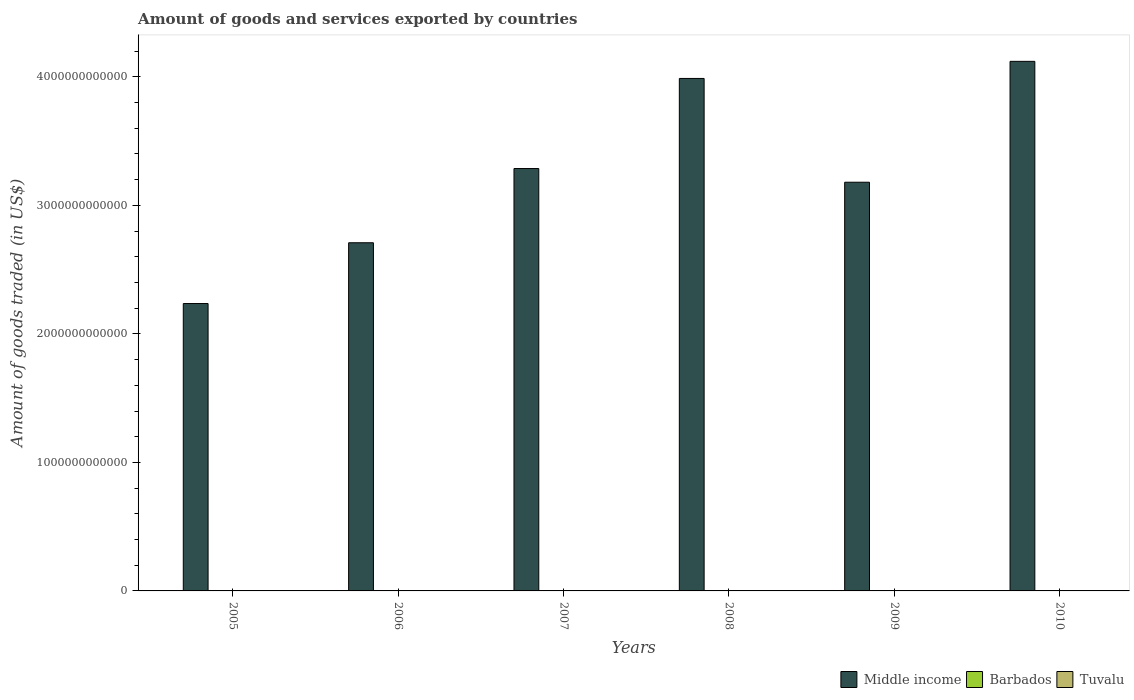How many groups of bars are there?
Your answer should be very brief. 6. Are the number of bars on each tick of the X-axis equal?
Offer a very short reply. Yes. How many bars are there on the 3rd tick from the left?
Your answer should be compact. 3. What is the label of the 4th group of bars from the left?
Offer a very short reply. 2008. In how many cases, is the number of bars for a given year not equal to the number of legend labels?
Your answer should be compact. 0. What is the total amount of goods and services exported in Middle income in 2007?
Your response must be concise. 3.29e+12. Across all years, what is the maximum total amount of goods and services exported in Barbados?
Offer a very short reply. 5.25e+08. Across all years, what is the minimum total amount of goods and services exported in Barbados?
Provide a short and direct response. 3.61e+08. In which year was the total amount of goods and services exported in Barbados maximum?
Your response must be concise. 2007. What is the total total amount of goods and services exported in Barbados in the graph?
Make the answer very short. 2.70e+09. What is the difference between the total amount of goods and services exported in Barbados in 2005 and that in 2007?
Your answer should be very brief. -1.64e+08. What is the difference between the total amount of goods and services exported in Barbados in 2008 and the total amount of goods and services exported in Tuvalu in 2010?
Your answer should be very brief. 4.79e+08. What is the average total amount of goods and services exported in Middle income per year?
Your answer should be very brief. 3.25e+12. In the year 2008, what is the difference between the total amount of goods and services exported in Tuvalu and total amount of goods and services exported in Barbados?
Provide a succinct answer. -4.89e+08. What is the ratio of the total amount of goods and services exported in Middle income in 2007 to that in 2009?
Provide a succinct answer. 1.03. Is the difference between the total amount of goods and services exported in Tuvalu in 2008 and 2010 greater than the difference between the total amount of goods and services exported in Barbados in 2008 and 2010?
Ensure brevity in your answer.  No. What is the difference between the highest and the second highest total amount of goods and services exported in Tuvalu?
Make the answer very short. 7.44e+06. What is the difference between the highest and the lowest total amount of goods and services exported in Tuvalu?
Provide a succinct answer. 9.68e+06. In how many years, is the total amount of goods and services exported in Tuvalu greater than the average total amount of goods and services exported in Tuvalu taken over all years?
Keep it short and to the point. 2. Is the sum of the total amount of goods and services exported in Middle income in 2007 and 2010 greater than the maximum total amount of goods and services exported in Barbados across all years?
Give a very brief answer. Yes. What does the 1st bar from the right in 2007 represents?
Make the answer very short. Tuvalu. How many years are there in the graph?
Offer a very short reply. 6. What is the difference between two consecutive major ticks on the Y-axis?
Your answer should be compact. 1.00e+12. Are the values on the major ticks of Y-axis written in scientific E-notation?
Provide a short and direct response. No. How are the legend labels stacked?
Provide a succinct answer. Horizontal. What is the title of the graph?
Your answer should be compact. Amount of goods and services exported by countries. Does "Vietnam" appear as one of the legend labels in the graph?
Your answer should be compact. No. What is the label or title of the Y-axis?
Offer a very short reply. Amount of goods traded (in US$). What is the Amount of goods traded (in US$) of Middle income in 2005?
Provide a succinct answer. 2.24e+12. What is the Amount of goods traded (in US$) of Barbados in 2005?
Ensure brevity in your answer.  3.61e+08. What is the Amount of goods traded (in US$) of Tuvalu in 2005?
Provide a succinct answer. 3.37e+05. What is the Amount of goods traded (in US$) of Middle income in 2006?
Your answer should be compact. 2.71e+12. What is the Amount of goods traded (in US$) of Barbados in 2006?
Keep it short and to the point. 5.10e+08. What is the Amount of goods traded (in US$) of Tuvalu in 2006?
Offer a very short reply. 4.18e+05. What is the Amount of goods traded (in US$) of Middle income in 2007?
Offer a terse response. 3.29e+12. What is the Amount of goods traded (in US$) in Barbados in 2007?
Make the answer very short. 5.25e+08. What is the Amount of goods traded (in US$) in Tuvalu in 2007?
Your response must be concise. 4.01e+05. What is the Amount of goods traded (in US$) in Middle income in 2008?
Give a very brief answer. 3.99e+12. What is the Amount of goods traded (in US$) in Barbados in 2008?
Give a very brief answer. 4.89e+08. What is the Amount of goods traded (in US$) of Tuvalu in 2008?
Provide a short and direct response. 5.43e+05. What is the Amount of goods traded (in US$) of Middle income in 2009?
Offer a very short reply. 3.18e+12. What is the Amount of goods traded (in US$) of Barbados in 2009?
Your answer should be compact. 3.80e+08. What is the Amount of goods traded (in US$) of Tuvalu in 2009?
Provide a short and direct response. 2.57e+06. What is the Amount of goods traded (in US$) of Middle income in 2010?
Make the answer very short. 4.12e+12. What is the Amount of goods traded (in US$) of Barbados in 2010?
Offer a terse response. 4.31e+08. What is the Amount of goods traded (in US$) in Tuvalu in 2010?
Offer a terse response. 1.00e+07. Across all years, what is the maximum Amount of goods traded (in US$) in Middle income?
Offer a very short reply. 4.12e+12. Across all years, what is the maximum Amount of goods traded (in US$) in Barbados?
Provide a short and direct response. 5.25e+08. Across all years, what is the maximum Amount of goods traded (in US$) in Tuvalu?
Keep it short and to the point. 1.00e+07. Across all years, what is the minimum Amount of goods traded (in US$) of Middle income?
Provide a succinct answer. 2.24e+12. Across all years, what is the minimum Amount of goods traded (in US$) of Barbados?
Offer a very short reply. 3.61e+08. Across all years, what is the minimum Amount of goods traded (in US$) in Tuvalu?
Provide a short and direct response. 3.37e+05. What is the total Amount of goods traded (in US$) of Middle income in the graph?
Offer a terse response. 1.95e+13. What is the total Amount of goods traded (in US$) of Barbados in the graph?
Offer a very short reply. 2.70e+09. What is the total Amount of goods traded (in US$) of Tuvalu in the graph?
Keep it short and to the point. 1.43e+07. What is the difference between the Amount of goods traded (in US$) in Middle income in 2005 and that in 2006?
Ensure brevity in your answer.  -4.73e+11. What is the difference between the Amount of goods traded (in US$) in Barbados in 2005 and that in 2006?
Your answer should be very brief. -1.49e+08. What is the difference between the Amount of goods traded (in US$) of Tuvalu in 2005 and that in 2006?
Offer a very short reply. -8.12e+04. What is the difference between the Amount of goods traded (in US$) of Middle income in 2005 and that in 2007?
Offer a very short reply. -1.05e+12. What is the difference between the Amount of goods traded (in US$) in Barbados in 2005 and that in 2007?
Your answer should be very brief. -1.64e+08. What is the difference between the Amount of goods traded (in US$) of Tuvalu in 2005 and that in 2007?
Offer a very short reply. -6.40e+04. What is the difference between the Amount of goods traded (in US$) of Middle income in 2005 and that in 2008?
Keep it short and to the point. -1.75e+12. What is the difference between the Amount of goods traded (in US$) in Barbados in 2005 and that in 2008?
Make the answer very short. -1.28e+08. What is the difference between the Amount of goods traded (in US$) in Tuvalu in 2005 and that in 2008?
Your answer should be compact. -2.06e+05. What is the difference between the Amount of goods traded (in US$) in Middle income in 2005 and that in 2009?
Ensure brevity in your answer.  -9.44e+11. What is the difference between the Amount of goods traded (in US$) in Barbados in 2005 and that in 2009?
Offer a very short reply. -1.87e+07. What is the difference between the Amount of goods traded (in US$) in Tuvalu in 2005 and that in 2009?
Give a very brief answer. -2.24e+06. What is the difference between the Amount of goods traded (in US$) of Middle income in 2005 and that in 2010?
Offer a terse response. -1.88e+12. What is the difference between the Amount of goods traded (in US$) in Barbados in 2005 and that in 2010?
Ensure brevity in your answer.  -6.92e+07. What is the difference between the Amount of goods traded (in US$) of Tuvalu in 2005 and that in 2010?
Offer a terse response. -9.68e+06. What is the difference between the Amount of goods traded (in US$) in Middle income in 2006 and that in 2007?
Your answer should be very brief. -5.77e+11. What is the difference between the Amount of goods traded (in US$) in Barbados in 2006 and that in 2007?
Provide a succinct answer. -1.54e+07. What is the difference between the Amount of goods traded (in US$) in Tuvalu in 2006 and that in 2007?
Provide a succinct answer. 1.71e+04. What is the difference between the Amount of goods traded (in US$) in Middle income in 2006 and that in 2008?
Your response must be concise. -1.28e+12. What is the difference between the Amount of goods traded (in US$) in Barbados in 2006 and that in 2008?
Offer a terse response. 2.07e+07. What is the difference between the Amount of goods traded (in US$) of Tuvalu in 2006 and that in 2008?
Your response must be concise. -1.25e+05. What is the difference between the Amount of goods traded (in US$) of Middle income in 2006 and that in 2009?
Your response must be concise. -4.71e+11. What is the difference between the Amount of goods traded (in US$) of Barbados in 2006 and that in 2009?
Provide a succinct answer. 1.30e+08. What is the difference between the Amount of goods traded (in US$) of Tuvalu in 2006 and that in 2009?
Keep it short and to the point. -2.16e+06. What is the difference between the Amount of goods traded (in US$) in Middle income in 2006 and that in 2010?
Make the answer very short. -1.41e+12. What is the difference between the Amount of goods traded (in US$) in Barbados in 2006 and that in 2010?
Ensure brevity in your answer.  7.94e+07. What is the difference between the Amount of goods traded (in US$) in Tuvalu in 2006 and that in 2010?
Your response must be concise. -9.60e+06. What is the difference between the Amount of goods traded (in US$) of Middle income in 2007 and that in 2008?
Make the answer very short. -7.01e+11. What is the difference between the Amount of goods traded (in US$) of Barbados in 2007 and that in 2008?
Your response must be concise. 3.60e+07. What is the difference between the Amount of goods traded (in US$) of Tuvalu in 2007 and that in 2008?
Provide a succinct answer. -1.42e+05. What is the difference between the Amount of goods traded (in US$) of Middle income in 2007 and that in 2009?
Make the answer very short. 1.06e+11. What is the difference between the Amount of goods traded (in US$) of Barbados in 2007 and that in 2009?
Your answer should be very brief. 1.45e+08. What is the difference between the Amount of goods traded (in US$) in Tuvalu in 2007 and that in 2009?
Your answer should be compact. -2.17e+06. What is the difference between the Amount of goods traded (in US$) of Middle income in 2007 and that in 2010?
Your answer should be compact. -8.34e+11. What is the difference between the Amount of goods traded (in US$) in Barbados in 2007 and that in 2010?
Ensure brevity in your answer.  9.48e+07. What is the difference between the Amount of goods traded (in US$) of Tuvalu in 2007 and that in 2010?
Your answer should be compact. -9.61e+06. What is the difference between the Amount of goods traded (in US$) of Middle income in 2008 and that in 2009?
Provide a short and direct response. 8.08e+11. What is the difference between the Amount of goods traded (in US$) of Barbados in 2008 and that in 2009?
Your response must be concise. 1.09e+08. What is the difference between the Amount of goods traded (in US$) in Tuvalu in 2008 and that in 2009?
Your answer should be compact. -2.03e+06. What is the difference between the Amount of goods traded (in US$) of Middle income in 2008 and that in 2010?
Offer a terse response. -1.33e+11. What is the difference between the Amount of goods traded (in US$) of Barbados in 2008 and that in 2010?
Offer a terse response. 5.88e+07. What is the difference between the Amount of goods traded (in US$) in Tuvalu in 2008 and that in 2010?
Offer a very short reply. -9.47e+06. What is the difference between the Amount of goods traded (in US$) of Middle income in 2009 and that in 2010?
Your answer should be compact. -9.41e+11. What is the difference between the Amount of goods traded (in US$) in Barbados in 2009 and that in 2010?
Make the answer very short. -5.04e+07. What is the difference between the Amount of goods traded (in US$) of Tuvalu in 2009 and that in 2010?
Your response must be concise. -7.44e+06. What is the difference between the Amount of goods traded (in US$) of Middle income in 2005 and the Amount of goods traded (in US$) of Barbados in 2006?
Keep it short and to the point. 2.24e+12. What is the difference between the Amount of goods traded (in US$) of Middle income in 2005 and the Amount of goods traded (in US$) of Tuvalu in 2006?
Keep it short and to the point. 2.24e+12. What is the difference between the Amount of goods traded (in US$) in Barbados in 2005 and the Amount of goods traded (in US$) in Tuvalu in 2006?
Ensure brevity in your answer.  3.61e+08. What is the difference between the Amount of goods traded (in US$) of Middle income in 2005 and the Amount of goods traded (in US$) of Barbados in 2007?
Your answer should be compact. 2.24e+12. What is the difference between the Amount of goods traded (in US$) of Middle income in 2005 and the Amount of goods traded (in US$) of Tuvalu in 2007?
Your answer should be compact. 2.24e+12. What is the difference between the Amount of goods traded (in US$) of Barbados in 2005 and the Amount of goods traded (in US$) of Tuvalu in 2007?
Provide a succinct answer. 3.61e+08. What is the difference between the Amount of goods traded (in US$) of Middle income in 2005 and the Amount of goods traded (in US$) of Barbados in 2008?
Your answer should be compact. 2.24e+12. What is the difference between the Amount of goods traded (in US$) in Middle income in 2005 and the Amount of goods traded (in US$) in Tuvalu in 2008?
Your response must be concise. 2.24e+12. What is the difference between the Amount of goods traded (in US$) of Barbados in 2005 and the Amount of goods traded (in US$) of Tuvalu in 2008?
Your answer should be very brief. 3.61e+08. What is the difference between the Amount of goods traded (in US$) in Middle income in 2005 and the Amount of goods traded (in US$) in Barbados in 2009?
Make the answer very short. 2.24e+12. What is the difference between the Amount of goods traded (in US$) of Middle income in 2005 and the Amount of goods traded (in US$) of Tuvalu in 2009?
Your response must be concise. 2.24e+12. What is the difference between the Amount of goods traded (in US$) of Barbados in 2005 and the Amount of goods traded (in US$) of Tuvalu in 2009?
Keep it short and to the point. 3.59e+08. What is the difference between the Amount of goods traded (in US$) in Middle income in 2005 and the Amount of goods traded (in US$) in Barbados in 2010?
Your response must be concise. 2.24e+12. What is the difference between the Amount of goods traded (in US$) in Middle income in 2005 and the Amount of goods traded (in US$) in Tuvalu in 2010?
Make the answer very short. 2.24e+12. What is the difference between the Amount of goods traded (in US$) of Barbados in 2005 and the Amount of goods traded (in US$) of Tuvalu in 2010?
Offer a terse response. 3.51e+08. What is the difference between the Amount of goods traded (in US$) in Middle income in 2006 and the Amount of goods traded (in US$) in Barbados in 2007?
Your response must be concise. 2.71e+12. What is the difference between the Amount of goods traded (in US$) of Middle income in 2006 and the Amount of goods traded (in US$) of Tuvalu in 2007?
Make the answer very short. 2.71e+12. What is the difference between the Amount of goods traded (in US$) of Barbados in 2006 and the Amount of goods traded (in US$) of Tuvalu in 2007?
Keep it short and to the point. 5.10e+08. What is the difference between the Amount of goods traded (in US$) in Middle income in 2006 and the Amount of goods traded (in US$) in Barbados in 2008?
Give a very brief answer. 2.71e+12. What is the difference between the Amount of goods traded (in US$) in Middle income in 2006 and the Amount of goods traded (in US$) in Tuvalu in 2008?
Make the answer very short. 2.71e+12. What is the difference between the Amount of goods traded (in US$) in Barbados in 2006 and the Amount of goods traded (in US$) in Tuvalu in 2008?
Your answer should be compact. 5.10e+08. What is the difference between the Amount of goods traded (in US$) in Middle income in 2006 and the Amount of goods traded (in US$) in Barbados in 2009?
Provide a short and direct response. 2.71e+12. What is the difference between the Amount of goods traded (in US$) of Middle income in 2006 and the Amount of goods traded (in US$) of Tuvalu in 2009?
Give a very brief answer. 2.71e+12. What is the difference between the Amount of goods traded (in US$) of Barbados in 2006 and the Amount of goods traded (in US$) of Tuvalu in 2009?
Make the answer very short. 5.08e+08. What is the difference between the Amount of goods traded (in US$) of Middle income in 2006 and the Amount of goods traded (in US$) of Barbados in 2010?
Your response must be concise. 2.71e+12. What is the difference between the Amount of goods traded (in US$) of Middle income in 2006 and the Amount of goods traded (in US$) of Tuvalu in 2010?
Offer a terse response. 2.71e+12. What is the difference between the Amount of goods traded (in US$) in Barbados in 2006 and the Amount of goods traded (in US$) in Tuvalu in 2010?
Ensure brevity in your answer.  5.00e+08. What is the difference between the Amount of goods traded (in US$) of Middle income in 2007 and the Amount of goods traded (in US$) of Barbados in 2008?
Your answer should be very brief. 3.29e+12. What is the difference between the Amount of goods traded (in US$) in Middle income in 2007 and the Amount of goods traded (in US$) in Tuvalu in 2008?
Offer a terse response. 3.29e+12. What is the difference between the Amount of goods traded (in US$) of Barbados in 2007 and the Amount of goods traded (in US$) of Tuvalu in 2008?
Provide a succinct answer. 5.25e+08. What is the difference between the Amount of goods traded (in US$) in Middle income in 2007 and the Amount of goods traded (in US$) in Barbados in 2009?
Provide a short and direct response. 3.29e+12. What is the difference between the Amount of goods traded (in US$) in Middle income in 2007 and the Amount of goods traded (in US$) in Tuvalu in 2009?
Ensure brevity in your answer.  3.29e+12. What is the difference between the Amount of goods traded (in US$) of Barbados in 2007 and the Amount of goods traded (in US$) of Tuvalu in 2009?
Make the answer very short. 5.23e+08. What is the difference between the Amount of goods traded (in US$) in Middle income in 2007 and the Amount of goods traded (in US$) in Barbados in 2010?
Offer a terse response. 3.29e+12. What is the difference between the Amount of goods traded (in US$) in Middle income in 2007 and the Amount of goods traded (in US$) in Tuvalu in 2010?
Provide a short and direct response. 3.29e+12. What is the difference between the Amount of goods traded (in US$) in Barbados in 2007 and the Amount of goods traded (in US$) in Tuvalu in 2010?
Your answer should be compact. 5.15e+08. What is the difference between the Amount of goods traded (in US$) of Middle income in 2008 and the Amount of goods traded (in US$) of Barbados in 2009?
Offer a terse response. 3.99e+12. What is the difference between the Amount of goods traded (in US$) of Middle income in 2008 and the Amount of goods traded (in US$) of Tuvalu in 2009?
Make the answer very short. 3.99e+12. What is the difference between the Amount of goods traded (in US$) of Barbados in 2008 and the Amount of goods traded (in US$) of Tuvalu in 2009?
Provide a short and direct response. 4.87e+08. What is the difference between the Amount of goods traded (in US$) of Middle income in 2008 and the Amount of goods traded (in US$) of Barbados in 2010?
Make the answer very short. 3.99e+12. What is the difference between the Amount of goods traded (in US$) of Middle income in 2008 and the Amount of goods traded (in US$) of Tuvalu in 2010?
Make the answer very short. 3.99e+12. What is the difference between the Amount of goods traded (in US$) of Barbados in 2008 and the Amount of goods traded (in US$) of Tuvalu in 2010?
Provide a short and direct response. 4.79e+08. What is the difference between the Amount of goods traded (in US$) of Middle income in 2009 and the Amount of goods traded (in US$) of Barbados in 2010?
Keep it short and to the point. 3.18e+12. What is the difference between the Amount of goods traded (in US$) of Middle income in 2009 and the Amount of goods traded (in US$) of Tuvalu in 2010?
Provide a short and direct response. 3.18e+12. What is the difference between the Amount of goods traded (in US$) in Barbados in 2009 and the Amount of goods traded (in US$) in Tuvalu in 2010?
Keep it short and to the point. 3.70e+08. What is the average Amount of goods traded (in US$) in Middle income per year?
Offer a very short reply. 3.25e+12. What is the average Amount of goods traded (in US$) of Barbados per year?
Give a very brief answer. 4.50e+08. What is the average Amount of goods traded (in US$) of Tuvalu per year?
Keep it short and to the point. 2.38e+06. In the year 2005, what is the difference between the Amount of goods traded (in US$) of Middle income and Amount of goods traded (in US$) of Barbados?
Offer a very short reply. 2.24e+12. In the year 2005, what is the difference between the Amount of goods traded (in US$) in Middle income and Amount of goods traded (in US$) in Tuvalu?
Give a very brief answer. 2.24e+12. In the year 2005, what is the difference between the Amount of goods traded (in US$) of Barbados and Amount of goods traded (in US$) of Tuvalu?
Provide a succinct answer. 3.61e+08. In the year 2006, what is the difference between the Amount of goods traded (in US$) in Middle income and Amount of goods traded (in US$) in Barbados?
Your answer should be very brief. 2.71e+12. In the year 2006, what is the difference between the Amount of goods traded (in US$) in Middle income and Amount of goods traded (in US$) in Tuvalu?
Your answer should be very brief. 2.71e+12. In the year 2006, what is the difference between the Amount of goods traded (in US$) in Barbados and Amount of goods traded (in US$) in Tuvalu?
Your answer should be very brief. 5.10e+08. In the year 2007, what is the difference between the Amount of goods traded (in US$) of Middle income and Amount of goods traded (in US$) of Barbados?
Your answer should be very brief. 3.29e+12. In the year 2007, what is the difference between the Amount of goods traded (in US$) in Middle income and Amount of goods traded (in US$) in Tuvalu?
Offer a terse response. 3.29e+12. In the year 2007, what is the difference between the Amount of goods traded (in US$) in Barbados and Amount of goods traded (in US$) in Tuvalu?
Offer a very short reply. 5.25e+08. In the year 2008, what is the difference between the Amount of goods traded (in US$) of Middle income and Amount of goods traded (in US$) of Barbados?
Make the answer very short. 3.99e+12. In the year 2008, what is the difference between the Amount of goods traded (in US$) of Middle income and Amount of goods traded (in US$) of Tuvalu?
Ensure brevity in your answer.  3.99e+12. In the year 2008, what is the difference between the Amount of goods traded (in US$) in Barbados and Amount of goods traded (in US$) in Tuvalu?
Provide a succinct answer. 4.89e+08. In the year 2009, what is the difference between the Amount of goods traded (in US$) of Middle income and Amount of goods traded (in US$) of Barbados?
Give a very brief answer. 3.18e+12. In the year 2009, what is the difference between the Amount of goods traded (in US$) in Middle income and Amount of goods traded (in US$) in Tuvalu?
Offer a terse response. 3.18e+12. In the year 2009, what is the difference between the Amount of goods traded (in US$) of Barbados and Amount of goods traded (in US$) of Tuvalu?
Your answer should be compact. 3.78e+08. In the year 2010, what is the difference between the Amount of goods traded (in US$) of Middle income and Amount of goods traded (in US$) of Barbados?
Your answer should be very brief. 4.12e+12. In the year 2010, what is the difference between the Amount of goods traded (in US$) in Middle income and Amount of goods traded (in US$) in Tuvalu?
Provide a succinct answer. 4.12e+12. In the year 2010, what is the difference between the Amount of goods traded (in US$) in Barbados and Amount of goods traded (in US$) in Tuvalu?
Your response must be concise. 4.21e+08. What is the ratio of the Amount of goods traded (in US$) in Middle income in 2005 to that in 2006?
Your answer should be compact. 0.83. What is the ratio of the Amount of goods traded (in US$) of Barbados in 2005 to that in 2006?
Give a very brief answer. 0.71. What is the ratio of the Amount of goods traded (in US$) in Tuvalu in 2005 to that in 2006?
Give a very brief answer. 0.81. What is the ratio of the Amount of goods traded (in US$) of Middle income in 2005 to that in 2007?
Your answer should be very brief. 0.68. What is the ratio of the Amount of goods traded (in US$) in Barbados in 2005 to that in 2007?
Offer a very short reply. 0.69. What is the ratio of the Amount of goods traded (in US$) of Tuvalu in 2005 to that in 2007?
Keep it short and to the point. 0.84. What is the ratio of the Amount of goods traded (in US$) in Middle income in 2005 to that in 2008?
Your answer should be compact. 0.56. What is the ratio of the Amount of goods traded (in US$) of Barbados in 2005 to that in 2008?
Make the answer very short. 0.74. What is the ratio of the Amount of goods traded (in US$) in Tuvalu in 2005 to that in 2008?
Make the answer very short. 0.62. What is the ratio of the Amount of goods traded (in US$) of Middle income in 2005 to that in 2009?
Your response must be concise. 0.7. What is the ratio of the Amount of goods traded (in US$) in Barbados in 2005 to that in 2009?
Ensure brevity in your answer.  0.95. What is the ratio of the Amount of goods traded (in US$) in Tuvalu in 2005 to that in 2009?
Your answer should be compact. 0.13. What is the ratio of the Amount of goods traded (in US$) in Middle income in 2005 to that in 2010?
Your answer should be very brief. 0.54. What is the ratio of the Amount of goods traded (in US$) in Barbados in 2005 to that in 2010?
Your answer should be compact. 0.84. What is the ratio of the Amount of goods traded (in US$) of Tuvalu in 2005 to that in 2010?
Ensure brevity in your answer.  0.03. What is the ratio of the Amount of goods traded (in US$) in Middle income in 2006 to that in 2007?
Give a very brief answer. 0.82. What is the ratio of the Amount of goods traded (in US$) in Barbados in 2006 to that in 2007?
Your answer should be very brief. 0.97. What is the ratio of the Amount of goods traded (in US$) in Tuvalu in 2006 to that in 2007?
Ensure brevity in your answer.  1.04. What is the ratio of the Amount of goods traded (in US$) of Middle income in 2006 to that in 2008?
Offer a terse response. 0.68. What is the ratio of the Amount of goods traded (in US$) of Barbados in 2006 to that in 2008?
Your response must be concise. 1.04. What is the ratio of the Amount of goods traded (in US$) in Tuvalu in 2006 to that in 2008?
Make the answer very short. 0.77. What is the ratio of the Amount of goods traded (in US$) in Middle income in 2006 to that in 2009?
Keep it short and to the point. 0.85. What is the ratio of the Amount of goods traded (in US$) in Barbados in 2006 to that in 2009?
Your answer should be very brief. 1.34. What is the ratio of the Amount of goods traded (in US$) in Tuvalu in 2006 to that in 2009?
Give a very brief answer. 0.16. What is the ratio of the Amount of goods traded (in US$) of Middle income in 2006 to that in 2010?
Offer a very short reply. 0.66. What is the ratio of the Amount of goods traded (in US$) in Barbados in 2006 to that in 2010?
Provide a succinct answer. 1.18. What is the ratio of the Amount of goods traded (in US$) of Tuvalu in 2006 to that in 2010?
Offer a terse response. 0.04. What is the ratio of the Amount of goods traded (in US$) in Middle income in 2007 to that in 2008?
Offer a terse response. 0.82. What is the ratio of the Amount of goods traded (in US$) of Barbados in 2007 to that in 2008?
Make the answer very short. 1.07. What is the ratio of the Amount of goods traded (in US$) of Tuvalu in 2007 to that in 2008?
Ensure brevity in your answer.  0.74. What is the ratio of the Amount of goods traded (in US$) in Middle income in 2007 to that in 2009?
Your answer should be very brief. 1.03. What is the ratio of the Amount of goods traded (in US$) of Barbados in 2007 to that in 2009?
Your response must be concise. 1.38. What is the ratio of the Amount of goods traded (in US$) in Tuvalu in 2007 to that in 2009?
Offer a terse response. 0.16. What is the ratio of the Amount of goods traded (in US$) of Middle income in 2007 to that in 2010?
Provide a succinct answer. 0.8. What is the ratio of the Amount of goods traded (in US$) in Barbados in 2007 to that in 2010?
Offer a terse response. 1.22. What is the ratio of the Amount of goods traded (in US$) of Middle income in 2008 to that in 2009?
Give a very brief answer. 1.25. What is the ratio of the Amount of goods traded (in US$) of Barbados in 2008 to that in 2009?
Give a very brief answer. 1.29. What is the ratio of the Amount of goods traded (in US$) of Tuvalu in 2008 to that in 2009?
Make the answer very short. 0.21. What is the ratio of the Amount of goods traded (in US$) in Barbados in 2008 to that in 2010?
Your response must be concise. 1.14. What is the ratio of the Amount of goods traded (in US$) in Tuvalu in 2008 to that in 2010?
Make the answer very short. 0.05. What is the ratio of the Amount of goods traded (in US$) of Middle income in 2009 to that in 2010?
Provide a succinct answer. 0.77. What is the ratio of the Amount of goods traded (in US$) of Barbados in 2009 to that in 2010?
Your answer should be very brief. 0.88. What is the ratio of the Amount of goods traded (in US$) in Tuvalu in 2009 to that in 2010?
Your response must be concise. 0.26. What is the difference between the highest and the second highest Amount of goods traded (in US$) in Middle income?
Give a very brief answer. 1.33e+11. What is the difference between the highest and the second highest Amount of goods traded (in US$) in Barbados?
Offer a terse response. 1.54e+07. What is the difference between the highest and the second highest Amount of goods traded (in US$) in Tuvalu?
Provide a succinct answer. 7.44e+06. What is the difference between the highest and the lowest Amount of goods traded (in US$) in Middle income?
Offer a terse response. 1.88e+12. What is the difference between the highest and the lowest Amount of goods traded (in US$) of Barbados?
Your answer should be compact. 1.64e+08. What is the difference between the highest and the lowest Amount of goods traded (in US$) of Tuvalu?
Make the answer very short. 9.68e+06. 